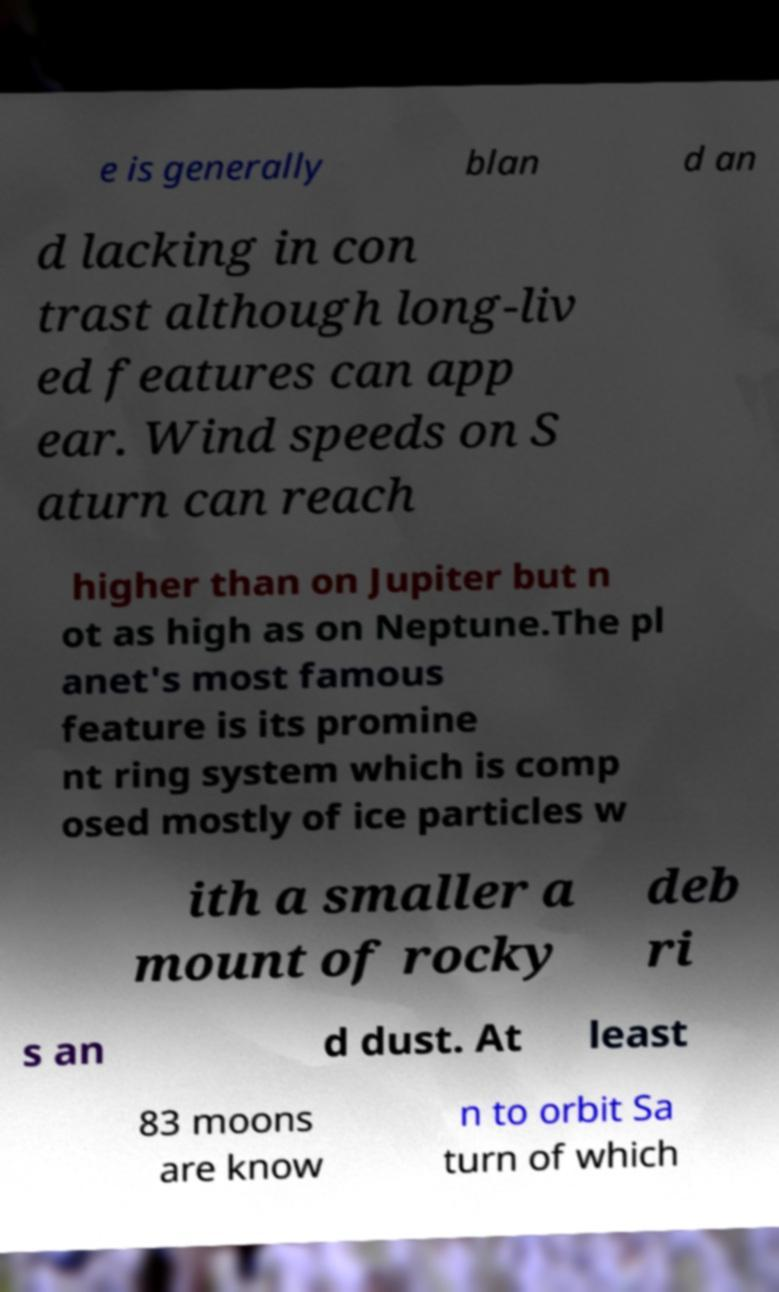For documentation purposes, I need the text within this image transcribed. Could you provide that? e is generally blan d an d lacking in con trast although long-liv ed features can app ear. Wind speeds on S aturn can reach higher than on Jupiter but n ot as high as on Neptune.The pl anet's most famous feature is its promine nt ring system which is comp osed mostly of ice particles w ith a smaller a mount of rocky deb ri s an d dust. At least 83 moons are know n to orbit Sa turn of which 